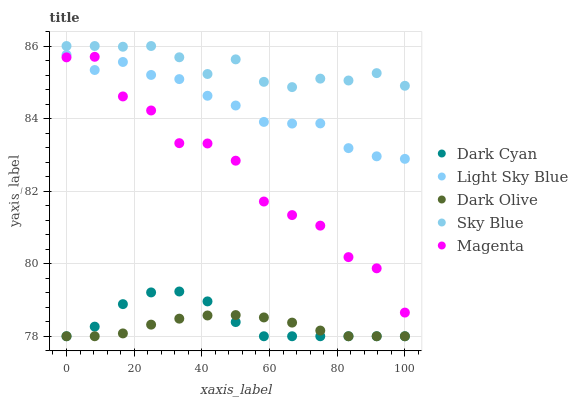Does Dark Olive have the minimum area under the curve?
Answer yes or no. Yes. Does Sky Blue have the maximum area under the curve?
Answer yes or no. Yes. Does Magenta have the minimum area under the curve?
Answer yes or no. No. Does Magenta have the maximum area under the curve?
Answer yes or no. No. Is Dark Olive the smoothest?
Answer yes or no. Yes. Is Magenta the roughest?
Answer yes or no. Yes. Is Sky Blue the smoothest?
Answer yes or no. No. Is Sky Blue the roughest?
Answer yes or no. No. Does Dark Cyan have the lowest value?
Answer yes or no. Yes. Does Magenta have the lowest value?
Answer yes or no. No. Does Sky Blue have the highest value?
Answer yes or no. Yes. Does Magenta have the highest value?
Answer yes or no. No. Is Dark Olive less than Light Sky Blue?
Answer yes or no. Yes. Is Sky Blue greater than Light Sky Blue?
Answer yes or no. Yes. Does Dark Cyan intersect Dark Olive?
Answer yes or no. Yes. Is Dark Cyan less than Dark Olive?
Answer yes or no. No. Is Dark Cyan greater than Dark Olive?
Answer yes or no. No. Does Dark Olive intersect Light Sky Blue?
Answer yes or no. No. 